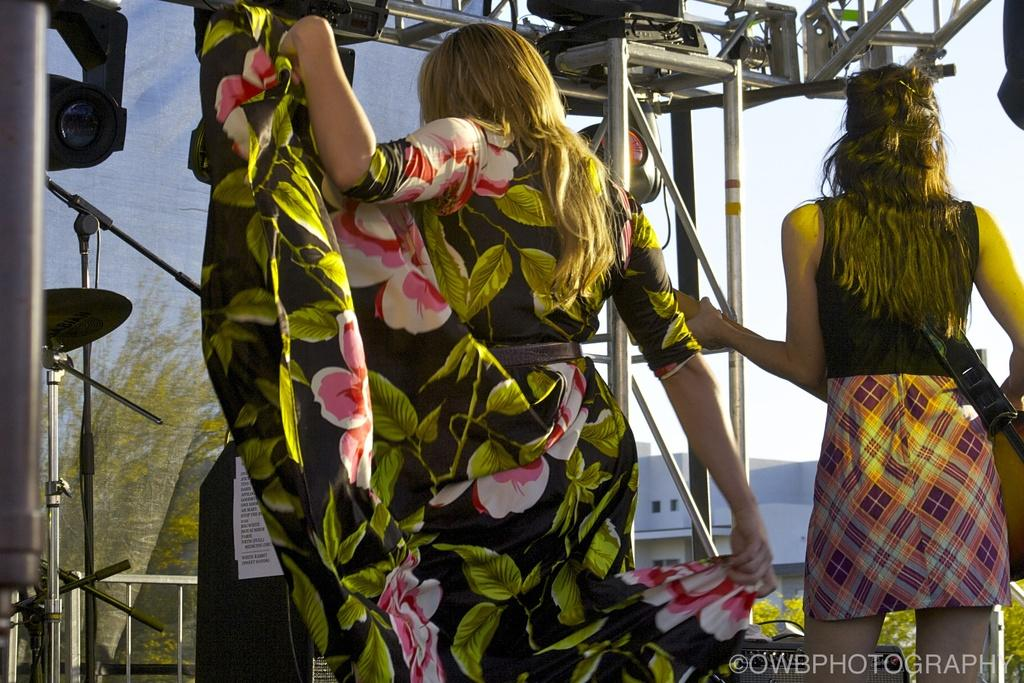How many women are present in the image? There are two women in the image. What is the appearance of one of the women's outfits? One of the women is wearing a colorful gown. What type of structure can be seen in the image? There is a building in the image. What equipment is present in the image? There are rods and a microphone in the image. What type of natural environment is visible in the image? There are trees in the image. What part of the natural environment is visible in the image? The sky is visible in the image. Can you tell me how many kitties are playing with the microphone in the image? There are no kitties present in the image, and therefore no such activity can be observed. 